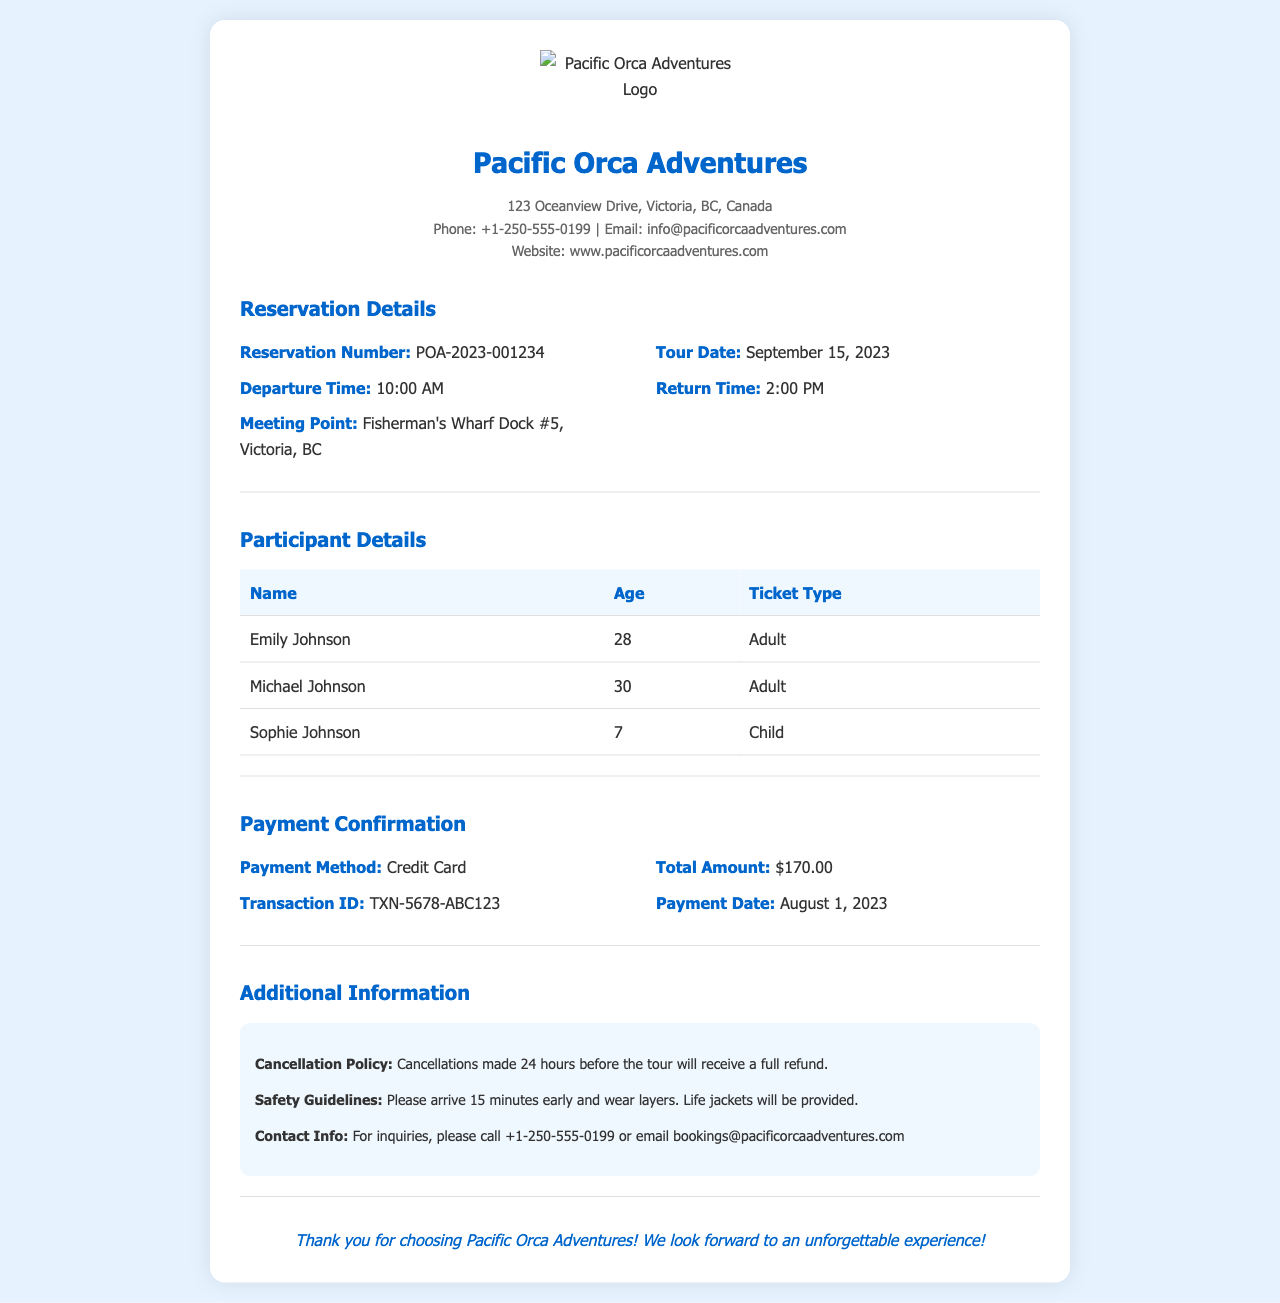What is the reservation number? The reservation number can be found in the Reservation Details section. It identifies this specific booking.
Answer: POA-2023-001234 What is the tour date? The tour date information is provided in the Reservation Details section of the receipt.
Answer: September 15, 2023 What is the total amount paid? The total amount paid can be found in the Payment Confirmation section of the receipt.
Answer: $170.00 Who is the youngest participant? The youngest participant's details are listed in the Participant Details section.
Answer: Sophie Johnson What time does the tour return? The return time is specified in the Reservation Details section and indicates when the participants will be back.
Answer: 2:00 PM What is the payment method? The payment method is provided in the Payment Confirmation section, giving insight into how the tour was paid for.
Answer: Credit Card What is the cancellation policy? The cancellation policy is mentioned under Additional Information, guiding customers on their options.
Answer: Cancellations made 24 hours before the tour will receive a full refund How many adult tickets were purchased? The number of adult tickets can be deduced from the Participant Details section by counting those classified as Adult.
Answer: 2 